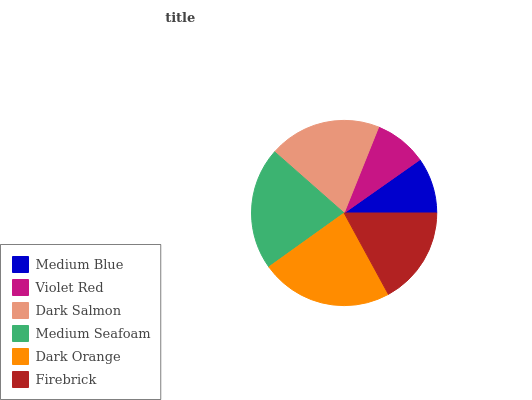Is Violet Red the minimum?
Answer yes or no. Yes. Is Dark Orange the maximum?
Answer yes or no. Yes. Is Dark Salmon the minimum?
Answer yes or no. No. Is Dark Salmon the maximum?
Answer yes or no. No. Is Dark Salmon greater than Violet Red?
Answer yes or no. Yes. Is Violet Red less than Dark Salmon?
Answer yes or no. Yes. Is Violet Red greater than Dark Salmon?
Answer yes or no. No. Is Dark Salmon less than Violet Red?
Answer yes or no. No. Is Dark Salmon the high median?
Answer yes or no. Yes. Is Firebrick the low median?
Answer yes or no. Yes. Is Firebrick the high median?
Answer yes or no. No. Is Dark Orange the low median?
Answer yes or no. No. 